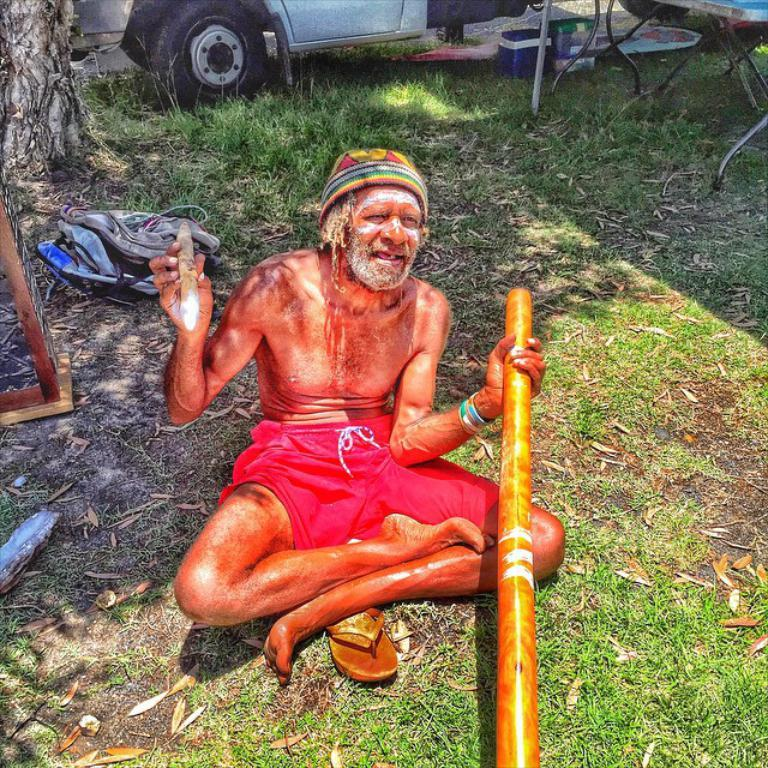What is the man in the image doing? The man is sitting on the grass in the image. What is the man holding in the image? The man is holding a stick in the image. What can be seen in the background of the image? There is a vehicle and a tree trunk visible in the background. How many rings can be seen on the tree trunk in the image? There are no rings visible on the tree trunk in the image. What type of deer can be seen grazing near the man in the image? There are no deer present in the image. 